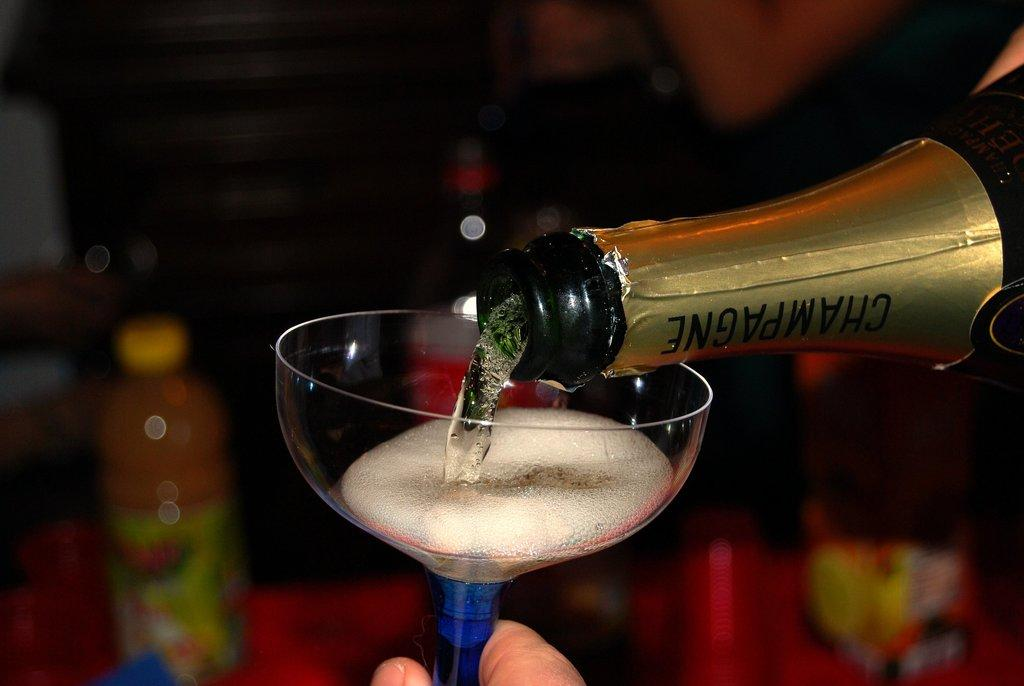What is contained in the glass that is visible in the image? There is a glass with a drink in the image. What action is being performed with the bottle in the image? Liquid is falling from a bottle in the image. Can you describe the other bottle visible in the image? There is another bottle visible in the background of the image. How would you describe the appearance of the background bottle? The background bottle appears blurry. Can you see any goldfish swimming in the glass with the drink? There are no goldfish present in the image; it features a glass with a drink and a bottle pouring liquid. 